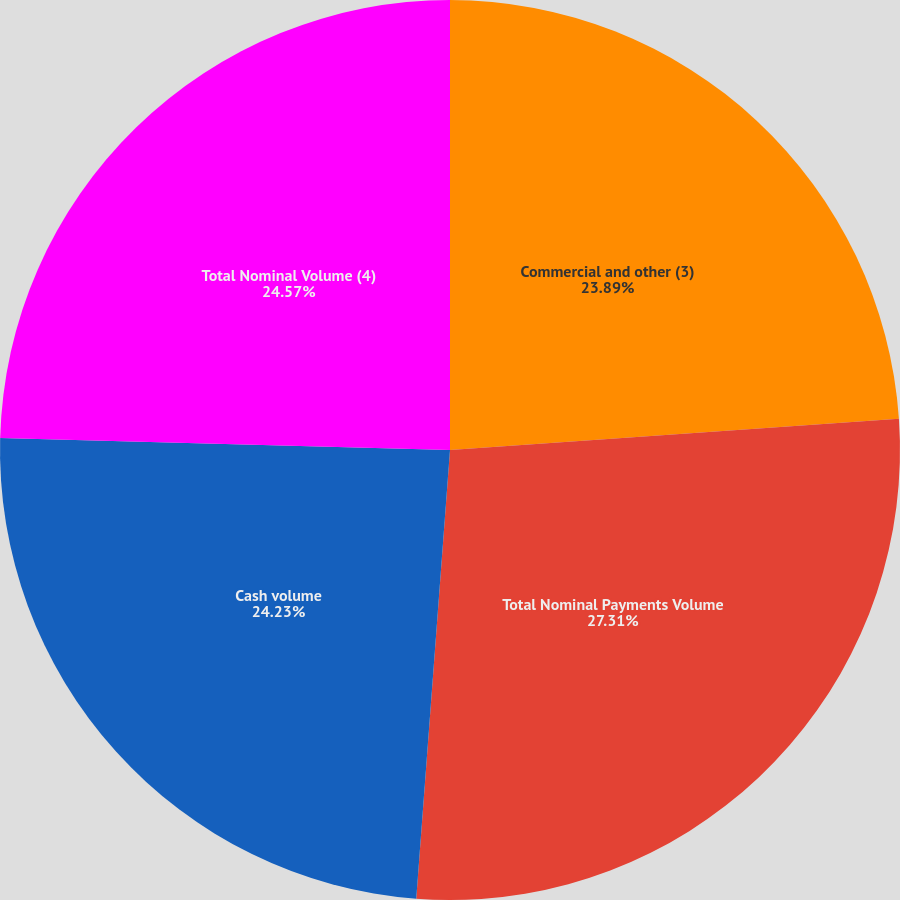Convert chart to OTSL. <chart><loc_0><loc_0><loc_500><loc_500><pie_chart><fcel>Commercial and other (3)<fcel>Total Nominal Payments Volume<fcel>Cash volume<fcel>Total Nominal Volume (4)<nl><fcel>23.89%<fcel>27.3%<fcel>24.23%<fcel>24.57%<nl></chart> 